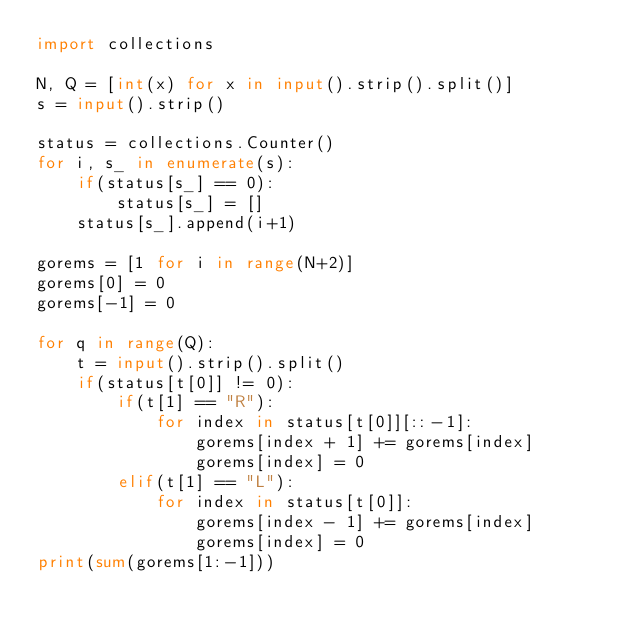Convert code to text. <code><loc_0><loc_0><loc_500><loc_500><_Python_>import collections

N, Q = [int(x) for x in input().strip().split()]
s = input().strip()

status = collections.Counter()
for i, s_ in enumerate(s):
    if(status[s_] == 0):
        status[s_] = []
    status[s_].append(i+1) 
    
gorems = [1 for i in range(N+2)]
gorems[0] = 0
gorems[-1] = 0

for q in range(Q):
    t = input().strip().split()
    if(status[t[0]] != 0):
        if(t[1] == "R"):
            for index in status[t[0]][::-1]:
                gorems[index + 1] += gorems[index] 
                gorems[index] = 0
        elif(t[1] == "L"):
            for index in status[t[0]]:
                gorems[index - 1] += gorems[index] 
                gorems[index] = 0
print(sum(gorems[1:-1]))</code> 